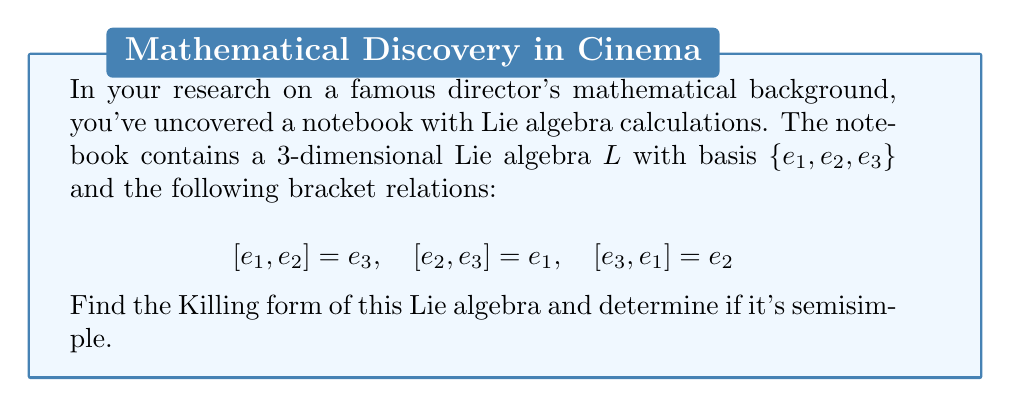Can you answer this question? 1) First, we need to find the adjoint representations of each basis element:

   $ad(e_1) = \begin{pmatrix} 0 & 0 & -1 \\ 0 & 0 & 0 \\ 0 & 1 & 0 \end{pmatrix}$
   
   $ad(e_2) = \begin{pmatrix} 0 & 0 & 0 \\ 0 & 0 & -1 \\ 1 & 0 & 0 \end{pmatrix}$
   
   $ad(e_3) = \begin{pmatrix} 0 & -1 & 0 \\ 1 & 0 & 0 \\ 0 & 0 & 0 \end{pmatrix}$

2) The Killing form $K(x,y)$ is defined as $K(x,y) = tr(ad(x)ad(y))$, where $tr$ denotes the trace.

3) Let's calculate the Killing form for each pair of basis elements:

   $K(e_1,e_1) = tr(ad(e_1)ad(e_1)) = tr\begin{pmatrix} -1 & 0 & 0 \\ 0 & -1 & 0 \\ 0 & 0 & -1 \end{pmatrix} = -3$
   
   $K(e_2,e_2) = K(e_3,e_3) = -3$ (by symmetry)
   
   $K(e_1,e_2) = K(e_2,e_1) = tr(ad(e_1)ad(e_2)) = tr\begin{pmatrix} 0 & 1 & 0 \\ -1 & 0 & 0 \\ 0 & 0 & 0 \end{pmatrix} = 0$
   
   $K(e_1,e_3) = K(e_3,e_1) = K(e_2,e_3) = K(e_3,e_2) = 0$ (similarly)

4) Therefore, the Killing form matrix is:

   $K = \begin{pmatrix} -3 & 0 & 0 \\ 0 & -3 & 0 \\ 0 & 0 & -3 \end{pmatrix}$

5) A Lie algebra is semisimple if and only if its Killing form is non-degenerate (i.e., has non-zero determinant).

6) The determinant of $K$ is $(-3)^3 = -27 \neq 0$, so the Killing form is non-degenerate.

Therefore, this Lie algebra is semisimple.
Answer: Killing form: $K = \begin{pmatrix} -3 & 0 & 0 \\ 0 & -3 & 0 \\ 0 & 0 & -3 \end{pmatrix}$. The Lie algebra is semisimple. 